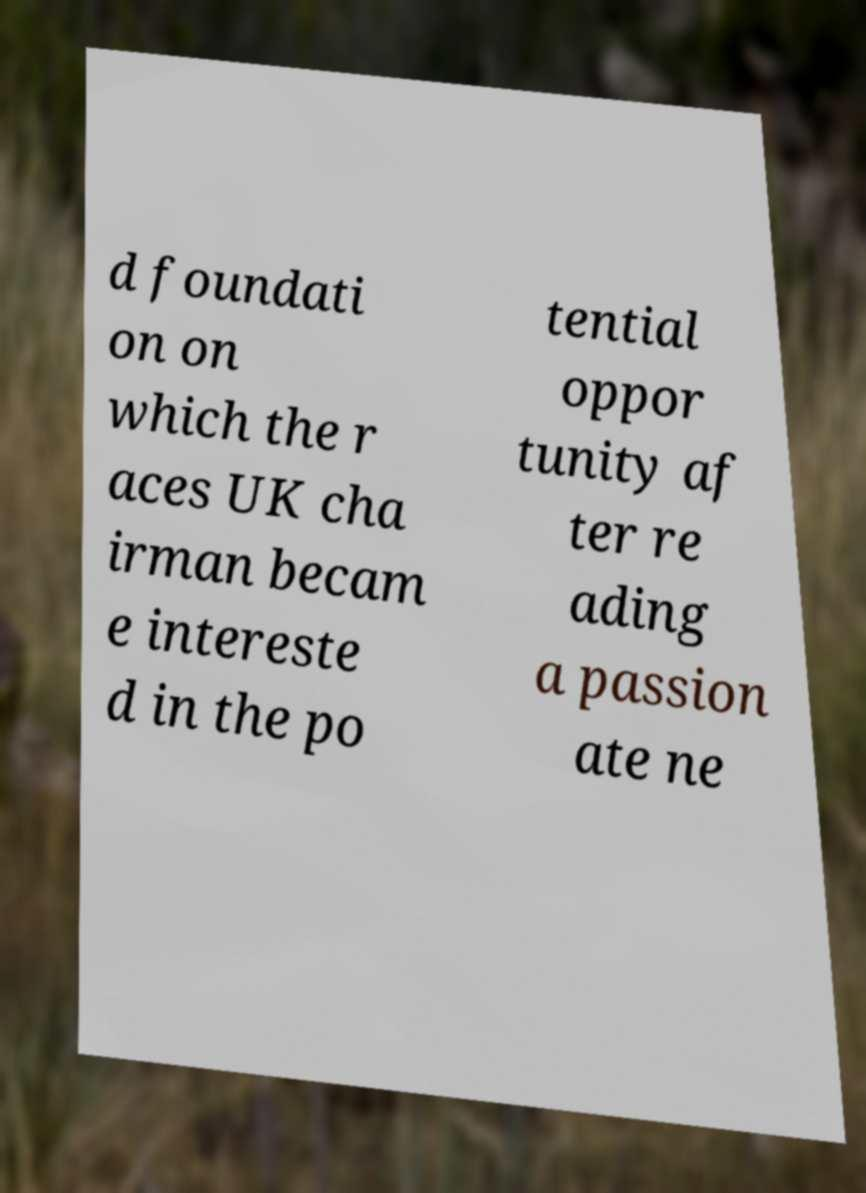Could you extract and type out the text from this image? d foundati on on which the r aces UK cha irman becam e intereste d in the po tential oppor tunity af ter re ading a passion ate ne 